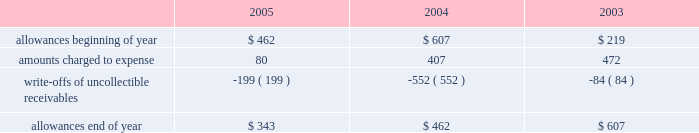Goodwill is reviewed annually during the fourth quarter for impairment .
In addition , the company performs an impairment analysis of other intangible assets based on the occurrence of other factors .
Such factors include , but are not limited to , signifi- cant changes in membership , state funding , medical contracts and provider networks and contracts .
An impairment loss is rec- ognized if the carrying value of intangible assets exceeds the implied fair value .
The company did not recognize any impair- ment losses for the periods presented .
Medical claims liabilities medical services costs include claims paid , claims reported but not yet paid ( inventory ) , estimates for claims incurred but not yet received ( ibnr ) and estimates for the costs necessary to process unpaid claims .
The estimates of medical claims liabilities are developed using standard actuarial methods based upon historical data for payment patterns , cost trends , product mix , seasonality , utiliza- tion of healthcare services and other relevant factors including product changes .
These estimates are continually reviewed and adjustments , if necessary , are reflected in the period known .
Management did not change actuarial methods during the years presented .
Management believes the amount of medical claims payable is reasonable and adequate to cover the company 2019s liabil- ity for unpaid claims as of december 31 , 2005 ; however , actual claim payments may differ from established estimates .
Revenue recognition the majority of the company 2019s medicaid managed care premi- um revenue is received monthly based on fixed rates per member as determined by state contracts .
Some contracts allow for addi- tional premium related to certain supplemental services provided such as maternity deliveries .
Revenue is recognized as earned over the covered period of services .
Revenues are recorded based on membership and eligibility data provided by the states , which may be adjusted by the states for updates to this membership and eligibility data .
These adjustments are immaterial in relation to total revenue recorded and are reflected in the period known .
Premiums collected in advance are recorded as unearned revenue .
The specialty services segment generates revenue under con- tracts with state and local government entities , our health plans and third-party customers .
Revenues for services are recognized when the services are provided or as ratably earned over the cov- ered period of services .
For performance-based contracts , the company does not recognize revenue subject to refund until data is sufficient to measure performance .
Such amounts are recorded as unearned revenue .
Revenues due to the company are recorded as premium and related receivables and recorded net of an allowance for uncol- lectible accounts based on historical trends and management 2019s judgment on the collectibility of these accounts .
Activity in the allowance for uncollectible accounts for the years ended december 31 is summarized below: .
Significant customers centene receives the majority of its revenues under contracts or subcontracts with state medicaid managed care programs .
The contracts , which expire on various dates between june 30 , 2006 and august 31 , 2008 , are expected to be renewed .
Contracts with the states of indiana , kansas , texas and wisconsin each accounted for 18% ( 18 % ) , 12% ( 12 % ) , 22% ( 22 % ) and 23% ( 23 % ) , respectively , of the company 2019s revenues for the year ended december 31 , 2005 .
Reinsurance centene has purchased reinsurance from third parties to cover eligible healthcare services .
The current reinsurance program covers 90% ( 90 % ) of inpatient healthcare expenses in excess of annual deductibles of $ 300 per member , up to a lifetime maximum of $ 2000 .
Centene 2019s medicaid managed care subsidiaries are respon- sible for inpatient charges in excess of an average daily per diem .
Reinsurance recoveries were $ 4014 , $ 3730 , and $ 5345 , in 2005 , 2004 , and 2003 , respectively .
Reinsurance expenses were approximately $ 4105 , $ 6724 , and $ 6185 in 2005 , 2004 , and 2003 , respectively .
Reinsurance recoveries , net of expenses , are included in medical costs .
Other income ( expense ) other income ( expense ) consists principally of investment income and interest expense .
Investment income is derived from the company 2019s cash , cash equivalents , restricted deposits and investments .
Interest expense relates to borrowings under our credit facility , mortgage interest , interest on capital leases and credit facility fees .
Income taxes deferred tax assets and liabilities are recorded for the future tax consequences attributable to differences between the financial statement carrying amounts of existing assets and liabilities and their respective tax bases .
Deferred tax assets and liabilities are measured using enacted tax rates expected to apply to taxable income in the years in which those temporary differences are expected to be recovered or settled .
The effect on deferred tax assets and liabilities of a change in tax rates is recognized in income in the period that includes the enactment date of the tax rate change .
Valuation allowances are provided when it is considered more likely than not that deferred tax assets will not be realized .
In determining if a deductible temporary difference or net operating loss can be realized , the company considers future reversals of .
What were net reinsurance recoveries in 2005 ( millions? )? 
Computations: (4014 - 4105)
Answer: -91.0. 